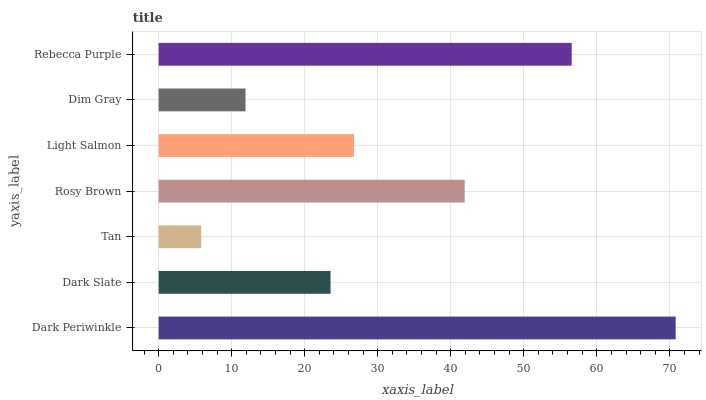Is Tan the minimum?
Answer yes or no. Yes. Is Dark Periwinkle the maximum?
Answer yes or no. Yes. Is Dark Slate the minimum?
Answer yes or no. No. Is Dark Slate the maximum?
Answer yes or no. No. Is Dark Periwinkle greater than Dark Slate?
Answer yes or no. Yes. Is Dark Slate less than Dark Periwinkle?
Answer yes or no. Yes. Is Dark Slate greater than Dark Periwinkle?
Answer yes or no. No. Is Dark Periwinkle less than Dark Slate?
Answer yes or no. No. Is Light Salmon the high median?
Answer yes or no. Yes. Is Light Salmon the low median?
Answer yes or no. Yes. Is Dark Slate the high median?
Answer yes or no. No. Is Tan the low median?
Answer yes or no. No. 